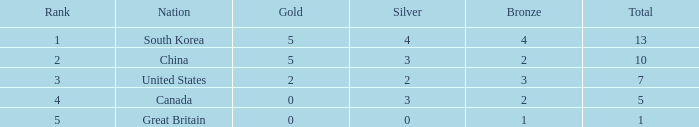What is the lowest Rank, when Nation is Great Britain, and when Bronze is less than 1? None. 